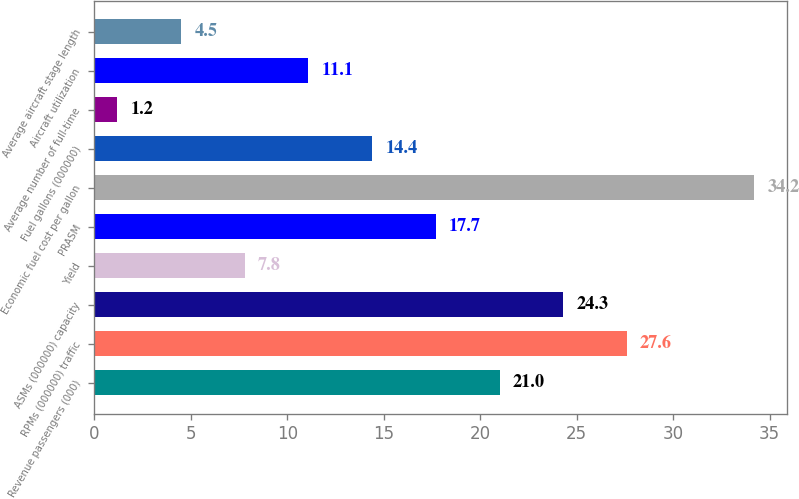Convert chart. <chart><loc_0><loc_0><loc_500><loc_500><bar_chart><fcel>Revenue passengers (000)<fcel>RPMs (000000) traffic<fcel>ASMs (000000) capacity<fcel>Yield<fcel>PRASM<fcel>Economic fuel cost per gallon<fcel>Fuel gallons (000000)<fcel>Average number of full-time<fcel>Aircraft utilization<fcel>Average aircraft stage length<nl><fcel>21<fcel>27.6<fcel>24.3<fcel>7.8<fcel>17.7<fcel>34.2<fcel>14.4<fcel>1.2<fcel>11.1<fcel>4.5<nl></chart> 